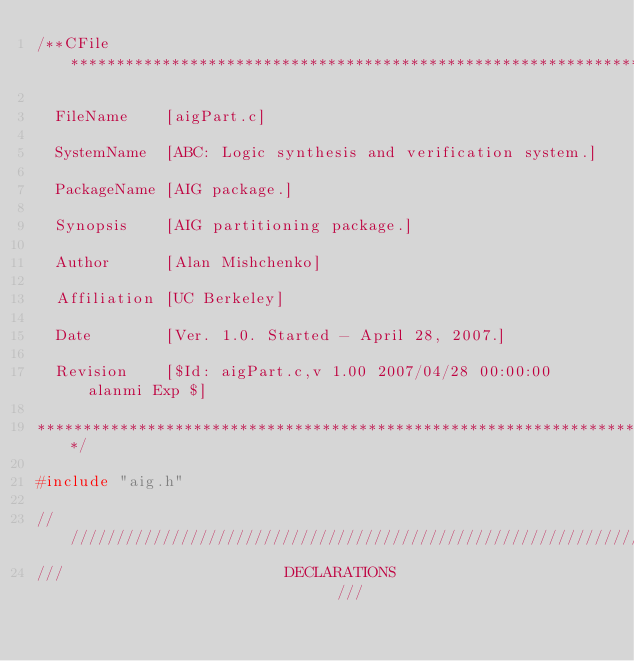<code> <loc_0><loc_0><loc_500><loc_500><_C_>/**CFile****************************************************************

  FileName    [aigPart.c]

  SystemName  [ABC: Logic synthesis and verification system.]

  PackageName [AIG package.]

  Synopsis    [AIG partitioning package.]

  Author      [Alan Mishchenko]
  
  Affiliation [UC Berkeley]

  Date        [Ver. 1.0. Started - April 28, 2007.]

  Revision    [$Id: aigPart.c,v 1.00 2007/04/28 00:00:00 alanmi Exp $]

***********************************************************************/

#include "aig.h"

////////////////////////////////////////////////////////////////////////
///                        DECLARATIONS                              ///</code> 